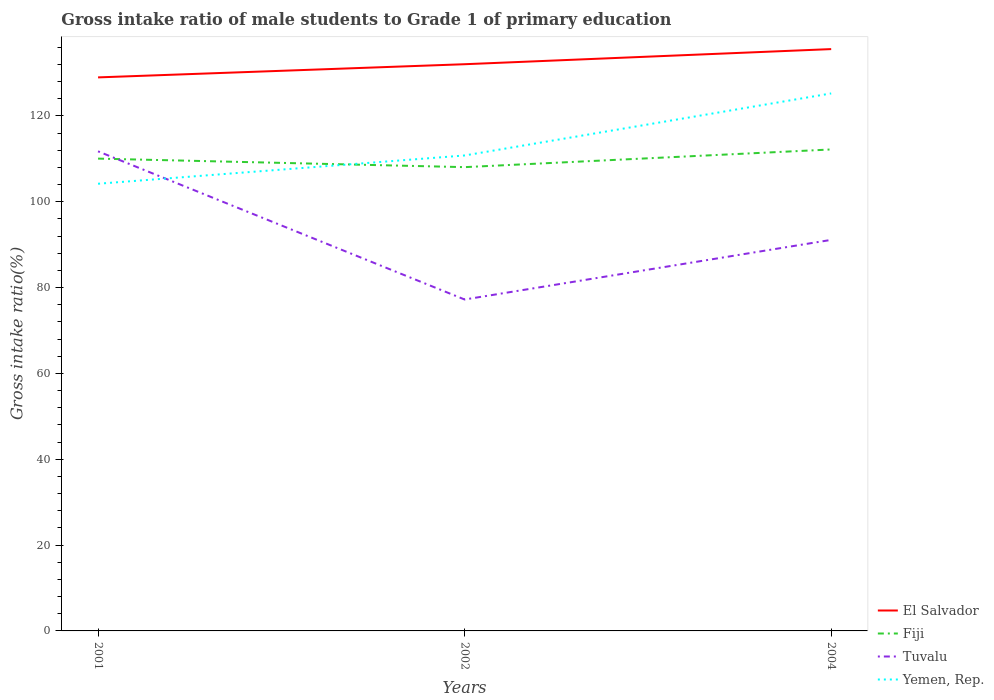How many different coloured lines are there?
Your response must be concise. 4. Across all years, what is the maximum gross intake ratio in Fiji?
Give a very brief answer. 108.08. In which year was the gross intake ratio in Yemen, Rep. maximum?
Provide a succinct answer. 2001. What is the total gross intake ratio in El Salvador in the graph?
Provide a succinct answer. -3.07. What is the difference between the highest and the second highest gross intake ratio in Fiji?
Provide a short and direct response. 4.12. What is the difference between the highest and the lowest gross intake ratio in Yemen, Rep.?
Your answer should be very brief. 1. Does the graph contain any zero values?
Your response must be concise. No. What is the title of the graph?
Your answer should be compact. Gross intake ratio of male students to Grade 1 of primary education. What is the label or title of the X-axis?
Offer a very short reply. Years. What is the label or title of the Y-axis?
Your answer should be compact. Gross intake ratio(%). What is the Gross intake ratio(%) of El Salvador in 2001?
Provide a succinct answer. 129. What is the Gross intake ratio(%) in Fiji in 2001?
Offer a terse response. 110.07. What is the Gross intake ratio(%) of Tuvalu in 2001?
Your response must be concise. 111.76. What is the Gross intake ratio(%) of Yemen, Rep. in 2001?
Provide a succinct answer. 104.21. What is the Gross intake ratio(%) in El Salvador in 2002?
Keep it short and to the point. 132.07. What is the Gross intake ratio(%) in Fiji in 2002?
Keep it short and to the point. 108.08. What is the Gross intake ratio(%) in Tuvalu in 2002?
Your response must be concise. 77.24. What is the Gross intake ratio(%) in Yemen, Rep. in 2002?
Your response must be concise. 110.8. What is the Gross intake ratio(%) in El Salvador in 2004?
Ensure brevity in your answer.  135.59. What is the Gross intake ratio(%) in Fiji in 2004?
Make the answer very short. 112.2. What is the Gross intake ratio(%) in Tuvalu in 2004?
Provide a short and direct response. 91.13. What is the Gross intake ratio(%) in Yemen, Rep. in 2004?
Your answer should be compact. 125.26. Across all years, what is the maximum Gross intake ratio(%) of El Salvador?
Your response must be concise. 135.59. Across all years, what is the maximum Gross intake ratio(%) of Fiji?
Keep it short and to the point. 112.2. Across all years, what is the maximum Gross intake ratio(%) in Tuvalu?
Offer a very short reply. 111.76. Across all years, what is the maximum Gross intake ratio(%) in Yemen, Rep.?
Provide a short and direct response. 125.26. Across all years, what is the minimum Gross intake ratio(%) of El Salvador?
Your response must be concise. 129. Across all years, what is the minimum Gross intake ratio(%) in Fiji?
Your answer should be very brief. 108.08. Across all years, what is the minimum Gross intake ratio(%) in Tuvalu?
Provide a short and direct response. 77.24. Across all years, what is the minimum Gross intake ratio(%) in Yemen, Rep.?
Provide a short and direct response. 104.21. What is the total Gross intake ratio(%) of El Salvador in the graph?
Your response must be concise. 396.65. What is the total Gross intake ratio(%) of Fiji in the graph?
Offer a very short reply. 330.35. What is the total Gross intake ratio(%) in Tuvalu in the graph?
Provide a succinct answer. 280.13. What is the total Gross intake ratio(%) of Yemen, Rep. in the graph?
Your answer should be very brief. 340.27. What is the difference between the Gross intake ratio(%) in El Salvador in 2001 and that in 2002?
Keep it short and to the point. -3.07. What is the difference between the Gross intake ratio(%) in Fiji in 2001 and that in 2002?
Your answer should be very brief. 1.99. What is the difference between the Gross intake ratio(%) in Tuvalu in 2001 and that in 2002?
Provide a short and direct response. 34.53. What is the difference between the Gross intake ratio(%) in Yemen, Rep. in 2001 and that in 2002?
Your response must be concise. -6.59. What is the difference between the Gross intake ratio(%) in El Salvador in 2001 and that in 2004?
Offer a terse response. -6.59. What is the difference between the Gross intake ratio(%) of Fiji in 2001 and that in 2004?
Ensure brevity in your answer.  -2.13. What is the difference between the Gross intake ratio(%) in Tuvalu in 2001 and that in 2004?
Offer a terse response. 20.64. What is the difference between the Gross intake ratio(%) of Yemen, Rep. in 2001 and that in 2004?
Offer a terse response. -21.05. What is the difference between the Gross intake ratio(%) in El Salvador in 2002 and that in 2004?
Offer a very short reply. -3.52. What is the difference between the Gross intake ratio(%) of Fiji in 2002 and that in 2004?
Provide a short and direct response. -4.12. What is the difference between the Gross intake ratio(%) of Tuvalu in 2002 and that in 2004?
Ensure brevity in your answer.  -13.89. What is the difference between the Gross intake ratio(%) of Yemen, Rep. in 2002 and that in 2004?
Offer a terse response. -14.46. What is the difference between the Gross intake ratio(%) of El Salvador in 2001 and the Gross intake ratio(%) of Fiji in 2002?
Your answer should be very brief. 20.92. What is the difference between the Gross intake ratio(%) of El Salvador in 2001 and the Gross intake ratio(%) of Tuvalu in 2002?
Provide a succinct answer. 51.76. What is the difference between the Gross intake ratio(%) of El Salvador in 2001 and the Gross intake ratio(%) of Yemen, Rep. in 2002?
Provide a succinct answer. 18.2. What is the difference between the Gross intake ratio(%) in Fiji in 2001 and the Gross intake ratio(%) in Tuvalu in 2002?
Make the answer very short. 32.83. What is the difference between the Gross intake ratio(%) of Fiji in 2001 and the Gross intake ratio(%) of Yemen, Rep. in 2002?
Provide a succinct answer. -0.73. What is the difference between the Gross intake ratio(%) of Tuvalu in 2001 and the Gross intake ratio(%) of Yemen, Rep. in 2002?
Your answer should be compact. 0.96. What is the difference between the Gross intake ratio(%) in El Salvador in 2001 and the Gross intake ratio(%) in Fiji in 2004?
Provide a succinct answer. 16.79. What is the difference between the Gross intake ratio(%) in El Salvador in 2001 and the Gross intake ratio(%) in Tuvalu in 2004?
Keep it short and to the point. 37.87. What is the difference between the Gross intake ratio(%) of El Salvador in 2001 and the Gross intake ratio(%) of Yemen, Rep. in 2004?
Make the answer very short. 3.74. What is the difference between the Gross intake ratio(%) in Fiji in 2001 and the Gross intake ratio(%) in Tuvalu in 2004?
Your response must be concise. 18.94. What is the difference between the Gross intake ratio(%) of Fiji in 2001 and the Gross intake ratio(%) of Yemen, Rep. in 2004?
Make the answer very short. -15.19. What is the difference between the Gross intake ratio(%) in Tuvalu in 2001 and the Gross intake ratio(%) in Yemen, Rep. in 2004?
Your answer should be very brief. -13.5. What is the difference between the Gross intake ratio(%) in El Salvador in 2002 and the Gross intake ratio(%) in Fiji in 2004?
Make the answer very short. 19.86. What is the difference between the Gross intake ratio(%) of El Salvador in 2002 and the Gross intake ratio(%) of Tuvalu in 2004?
Give a very brief answer. 40.94. What is the difference between the Gross intake ratio(%) in El Salvador in 2002 and the Gross intake ratio(%) in Yemen, Rep. in 2004?
Ensure brevity in your answer.  6.81. What is the difference between the Gross intake ratio(%) in Fiji in 2002 and the Gross intake ratio(%) in Tuvalu in 2004?
Offer a very short reply. 16.95. What is the difference between the Gross intake ratio(%) in Fiji in 2002 and the Gross intake ratio(%) in Yemen, Rep. in 2004?
Provide a short and direct response. -17.18. What is the difference between the Gross intake ratio(%) of Tuvalu in 2002 and the Gross intake ratio(%) of Yemen, Rep. in 2004?
Offer a very short reply. -48.03. What is the average Gross intake ratio(%) in El Salvador per year?
Your answer should be very brief. 132.22. What is the average Gross intake ratio(%) in Fiji per year?
Give a very brief answer. 110.12. What is the average Gross intake ratio(%) in Tuvalu per year?
Give a very brief answer. 93.38. What is the average Gross intake ratio(%) in Yemen, Rep. per year?
Provide a short and direct response. 113.42. In the year 2001, what is the difference between the Gross intake ratio(%) of El Salvador and Gross intake ratio(%) of Fiji?
Offer a terse response. 18.93. In the year 2001, what is the difference between the Gross intake ratio(%) of El Salvador and Gross intake ratio(%) of Tuvalu?
Provide a short and direct response. 17.23. In the year 2001, what is the difference between the Gross intake ratio(%) in El Salvador and Gross intake ratio(%) in Yemen, Rep.?
Ensure brevity in your answer.  24.79. In the year 2001, what is the difference between the Gross intake ratio(%) of Fiji and Gross intake ratio(%) of Tuvalu?
Your answer should be compact. -1.7. In the year 2001, what is the difference between the Gross intake ratio(%) of Fiji and Gross intake ratio(%) of Yemen, Rep.?
Offer a very short reply. 5.86. In the year 2001, what is the difference between the Gross intake ratio(%) of Tuvalu and Gross intake ratio(%) of Yemen, Rep.?
Offer a terse response. 7.55. In the year 2002, what is the difference between the Gross intake ratio(%) in El Salvador and Gross intake ratio(%) in Fiji?
Make the answer very short. 23.99. In the year 2002, what is the difference between the Gross intake ratio(%) in El Salvador and Gross intake ratio(%) in Tuvalu?
Provide a short and direct response. 54.83. In the year 2002, what is the difference between the Gross intake ratio(%) in El Salvador and Gross intake ratio(%) in Yemen, Rep.?
Ensure brevity in your answer.  21.26. In the year 2002, what is the difference between the Gross intake ratio(%) of Fiji and Gross intake ratio(%) of Tuvalu?
Make the answer very short. 30.84. In the year 2002, what is the difference between the Gross intake ratio(%) of Fiji and Gross intake ratio(%) of Yemen, Rep.?
Give a very brief answer. -2.72. In the year 2002, what is the difference between the Gross intake ratio(%) of Tuvalu and Gross intake ratio(%) of Yemen, Rep.?
Provide a short and direct response. -33.57. In the year 2004, what is the difference between the Gross intake ratio(%) of El Salvador and Gross intake ratio(%) of Fiji?
Give a very brief answer. 23.39. In the year 2004, what is the difference between the Gross intake ratio(%) of El Salvador and Gross intake ratio(%) of Tuvalu?
Your answer should be very brief. 44.46. In the year 2004, what is the difference between the Gross intake ratio(%) in El Salvador and Gross intake ratio(%) in Yemen, Rep.?
Offer a very short reply. 10.33. In the year 2004, what is the difference between the Gross intake ratio(%) of Fiji and Gross intake ratio(%) of Tuvalu?
Offer a terse response. 21.07. In the year 2004, what is the difference between the Gross intake ratio(%) in Fiji and Gross intake ratio(%) in Yemen, Rep.?
Provide a succinct answer. -13.06. In the year 2004, what is the difference between the Gross intake ratio(%) of Tuvalu and Gross intake ratio(%) of Yemen, Rep.?
Your answer should be compact. -34.13. What is the ratio of the Gross intake ratio(%) of El Salvador in 2001 to that in 2002?
Provide a short and direct response. 0.98. What is the ratio of the Gross intake ratio(%) in Fiji in 2001 to that in 2002?
Your answer should be very brief. 1.02. What is the ratio of the Gross intake ratio(%) in Tuvalu in 2001 to that in 2002?
Offer a terse response. 1.45. What is the ratio of the Gross intake ratio(%) of Yemen, Rep. in 2001 to that in 2002?
Your response must be concise. 0.94. What is the ratio of the Gross intake ratio(%) of El Salvador in 2001 to that in 2004?
Ensure brevity in your answer.  0.95. What is the ratio of the Gross intake ratio(%) in Tuvalu in 2001 to that in 2004?
Ensure brevity in your answer.  1.23. What is the ratio of the Gross intake ratio(%) of Yemen, Rep. in 2001 to that in 2004?
Give a very brief answer. 0.83. What is the ratio of the Gross intake ratio(%) of Fiji in 2002 to that in 2004?
Your answer should be compact. 0.96. What is the ratio of the Gross intake ratio(%) in Tuvalu in 2002 to that in 2004?
Ensure brevity in your answer.  0.85. What is the ratio of the Gross intake ratio(%) in Yemen, Rep. in 2002 to that in 2004?
Provide a succinct answer. 0.88. What is the difference between the highest and the second highest Gross intake ratio(%) in El Salvador?
Your response must be concise. 3.52. What is the difference between the highest and the second highest Gross intake ratio(%) in Fiji?
Offer a terse response. 2.13. What is the difference between the highest and the second highest Gross intake ratio(%) of Tuvalu?
Give a very brief answer. 20.64. What is the difference between the highest and the second highest Gross intake ratio(%) of Yemen, Rep.?
Offer a very short reply. 14.46. What is the difference between the highest and the lowest Gross intake ratio(%) of El Salvador?
Ensure brevity in your answer.  6.59. What is the difference between the highest and the lowest Gross intake ratio(%) of Fiji?
Your response must be concise. 4.12. What is the difference between the highest and the lowest Gross intake ratio(%) of Tuvalu?
Make the answer very short. 34.53. What is the difference between the highest and the lowest Gross intake ratio(%) of Yemen, Rep.?
Give a very brief answer. 21.05. 